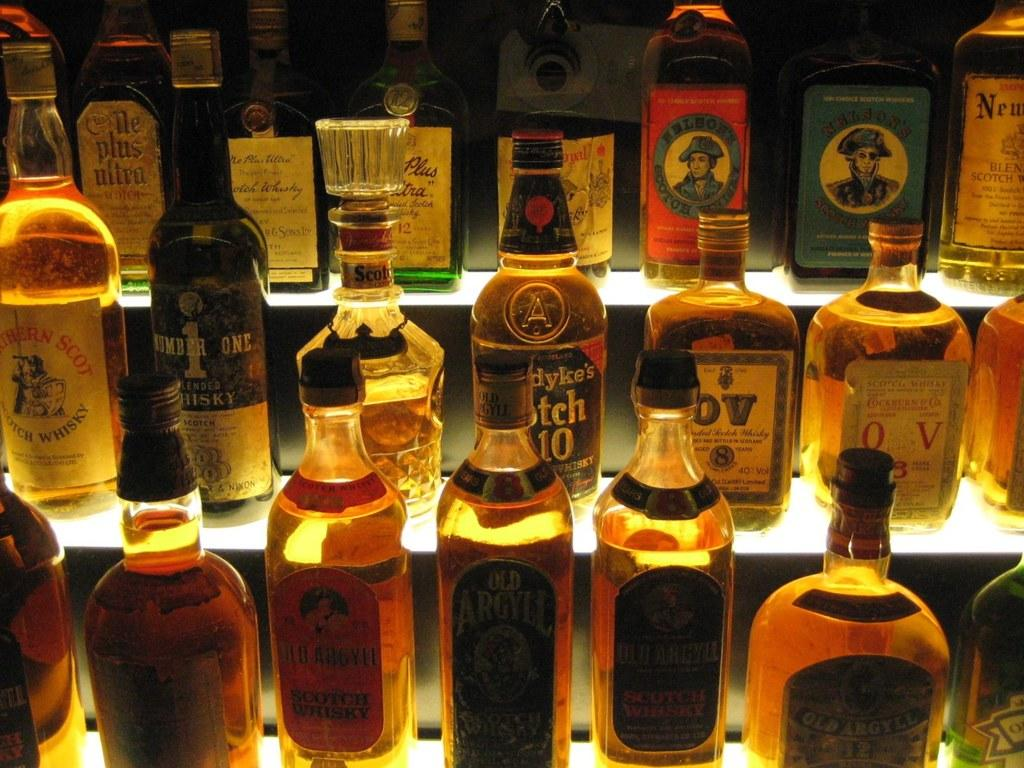What is the main subject of the image? The main subject of the image is a group of bottles. Where are the bottles located in the image? The bottles are kept on a showcase. How many clovers are present in the image? There are no clovers present in the image; it features a group of bottles on a showcase. What is the appropriate response when the bottles say good-bye in the image? There is no indication that the bottles are saying good-bye or capable of speech in the image. 